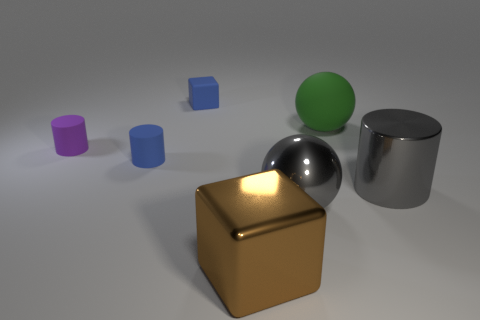What material is the big thing that is behind the cylinder right of the block to the right of the blue block?
Your answer should be very brief. Rubber. What number of cubes are green objects or brown metallic things?
Your answer should be very brief. 1. Is there any other thing that is the same shape as the brown object?
Your answer should be very brief. Yes. Is the number of blue rubber cylinders to the right of the large cube greater than the number of brown metal blocks that are left of the tiny blue cylinder?
Give a very brief answer. No. How many rubber things are behind the big green sphere that is behind the big cylinder?
Provide a short and direct response. 1. What number of things are tiny cylinders or large gray metallic cylinders?
Make the answer very short. 3. What material is the large green object?
Keep it short and to the point. Rubber. How many things are behind the matte ball and on the right side of the big matte sphere?
Keep it short and to the point. 0. Do the gray shiny cylinder and the purple matte object have the same size?
Keep it short and to the point. No. There is a gray shiny object that is left of the gray metal cylinder; is its size the same as the gray cylinder?
Make the answer very short. Yes. 